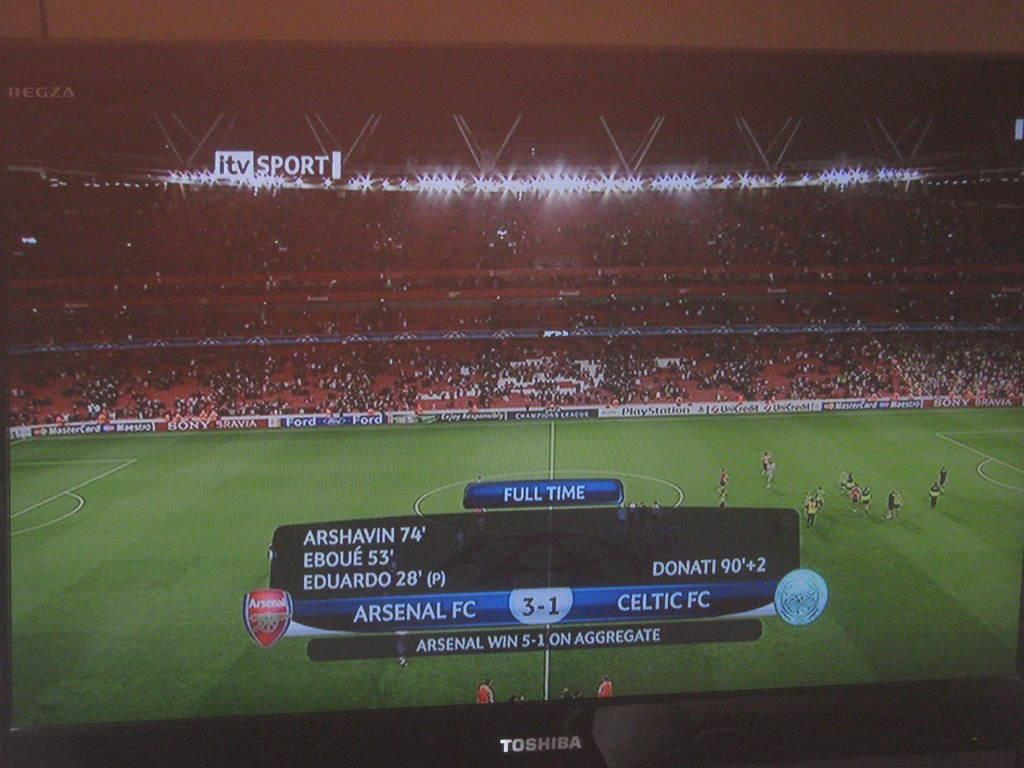<image>
Summarize the visual content of the image. Arsenal FC beats Celtic FC 3 to 1 in a soccer match on itv Sport. 